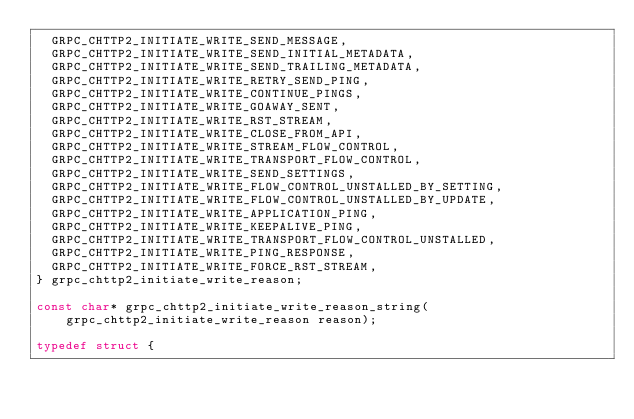<code> <loc_0><loc_0><loc_500><loc_500><_C_>  GRPC_CHTTP2_INITIATE_WRITE_SEND_MESSAGE,
  GRPC_CHTTP2_INITIATE_WRITE_SEND_INITIAL_METADATA,
  GRPC_CHTTP2_INITIATE_WRITE_SEND_TRAILING_METADATA,
  GRPC_CHTTP2_INITIATE_WRITE_RETRY_SEND_PING,
  GRPC_CHTTP2_INITIATE_WRITE_CONTINUE_PINGS,
  GRPC_CHTTP2_INITIATE_WRITE_GOAWAY_SENT,
  GRPC_CHTTP2_INITIATE_WRITE_RST_STREAM,
  GRPC_CHTTP2_INITIATE_WRITE_CLOSE_FROM_API,
  GRPC_CHTTP2_INITIATE_WRITE_STREAM_FLOW_CONTROL,
  GRPC_CHTTP2_INITIATE_WRITE_TRANSPORT_FLOW_CONTROL,
  GRPC_CHTTP2_INITIATE_WRITE_SEND_SETTINGS,
  GRPC_CHTTP2_INITIATE_WRITE_FLOW_CONTROL_UNSTALLED_BY_SETTING,
  GRPC_CHTTP2_INITIATE_WRITE_FLOW_CONTROL_UNSTALLED_BY_UPDATE,
  GRPC_CHTTP2_INITIATE_WRITE_APPLICATION_PING,
  GRPC_CHTTP2_INITIATE_WRITE_KEEPALIVE_PING,
  GRPC_CHTTP2_INITIATE_WRITE_TRANSPORT_FLOW_CONTROL_UNSTALLED,
  GRPC_CHTTP2_INITIATE_WRITE_PING_RESPONSE,
  GRPC_CHTTP2_INITIATE_WRITE_FORCE_RST_STREAM,
} grpc_chttp2_initiate_write_reason;

const char* grpc_chttp2_initiate_write_reason_string(
    grpc_chttp2_initiate_write_reason reason);

typedef struct {</code> 